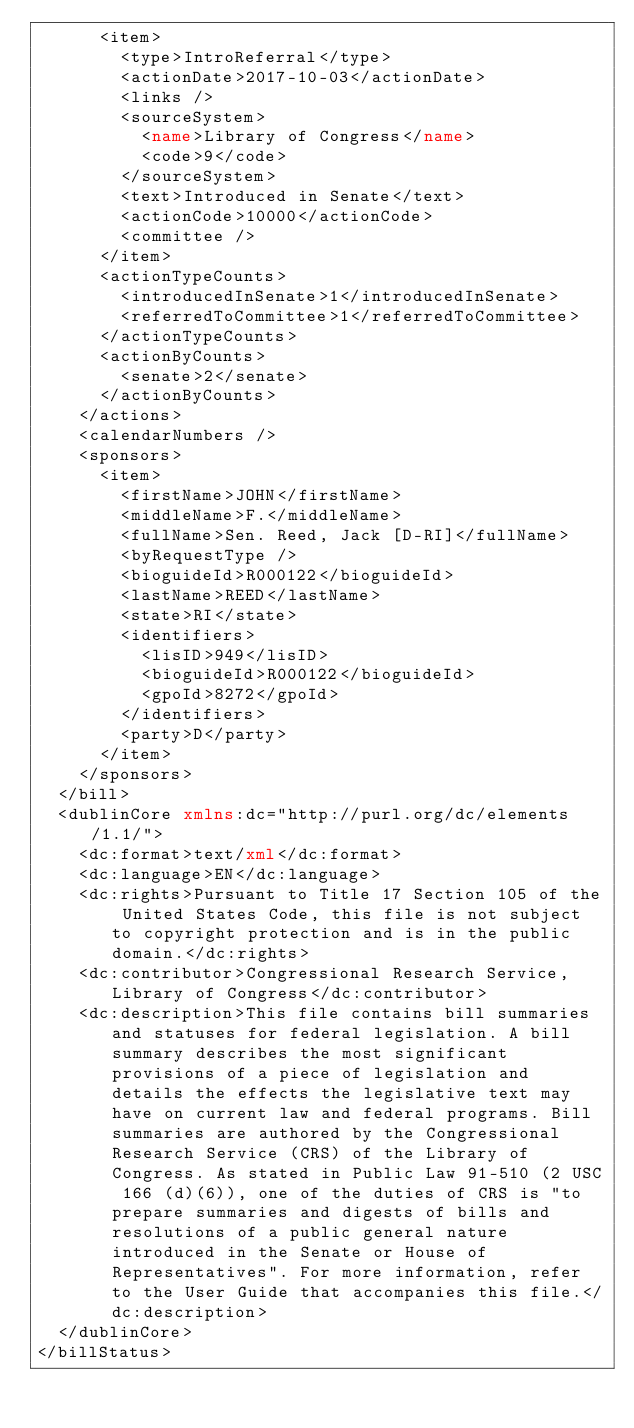Convert code to text. <code><loc_0><loc_0><loc_500><loc_500><_XML_>      <item>
        <type>IntroReferral</type>
        <actionDate>2017-10-03</actionDate>
        <links />
        <sourceSystem>
          <name>Library of Congress</name>
          <code>9</code>
        </sourceSystem>
        <text>Introduced in Senate</text>
        <actionCode>10000</actionCode>
        <committee />
      </item>
      <actionTypeCounts>
        <introducedInSenate>1</introducedInSenate>
        <referredToCommittee>1</referredToCommittee>
      </actionTypeCounts>
      <actionByCounts>
        <senate>2</senate>
      </actionByCounts>
    </actions>
    <calendarNumbers />
    <sponsors>
      <item>
        <firstName>JOHN</firstName>
        <middleName>F.</middleName>
        <fullName>Sen. Reed, Jack [D-RI]</fullName>
        <byRequestType />
        <bioguideId>R000122</bioguideId>
        <lastName>REED</lastName>
        <state>RI</state>
        <identifiers>
          <lisID>949</lisID>
          <bioguideId>R000122</bioguideId>
          <gpoId>8272</gpoId>
        </identifiers>
        <party>D</party>
      </item>
    </sponsors>
  </bill>
  <dublinCore xmlns:dc="http://purl.org/dc/elements/1.1/">
    <dc:format>text/xml</dc:format>
    <dc:language>EN</dc:language>
    <dc:rights>Pursuant to Title 17 Section 105 of the United States Code, this file is not subject to copyright protection and is in the public domain.</dc:rights>
    <dc:contributor>Congressional Research Service, Library of Congress</dc:contributor>
    <dc:description>This file contains bill summaries and statuses for federal legislation. A bill summary describes the most significant provisions of a piece of legislation and details the effects the legislative text may have on current law and federal programs. Bill summaries are authored by the Congressional Research Service (CRS) of the Library of Congress. As stated in Public Law 91-510 (2 USC 166 (d)(6)), one of the duties of CRS is "to prepare summaries and digests of bills and resolutions of a public general nature introduced in the Senate or House of Representatives". For more information, refer to the User Guide that accompanies this file.</dc:description>
  </dublinCore>
</billStatus>

</code> 